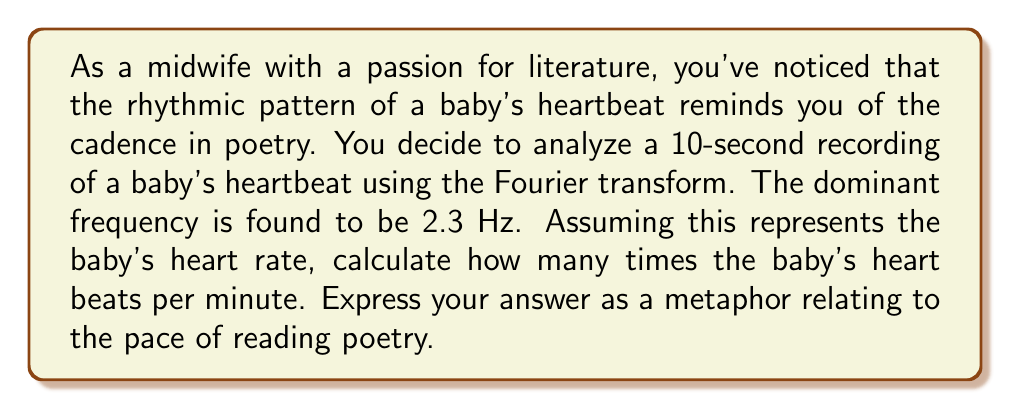Provide a solution to this math problem. To solve this problem, we need to follow these steps:

1. Understand the given information:
   - The dominant frequency from the Fourier transform is 2.3 Hz
   - Hz means cycles per second

2. Convert the frequency to beats per minute:
   $$\text{Beats per minute} = \text{Frequency (Hz)} \times 60 \text{ seconds/minute}$$
   $$\text{Beats per minute} = 2.3 \text{ Hz} \times 60 \text{ seconds/minute}$$
   $$\text{Beats per minute} = 138 \text{ beats/minute}$$

3. Relate this to poetry:
   In poetry, a common meter is iambic pentameter, which has 10 syllables per line. If we consider each heartbeat as a syllable, we can express the heart rate in terms of lines of iambic pentameter per minute:

   $$\text{Lines per minute} = \frac{138 \text{ beats/minute}}{10 \text{ syllables/line}} = 13.8 \text{ lines/minute}$$

4. Create a poetic metaphor:
   We can say the baby's heart beats at the pace of reading about 14 lines of iambic pentameter per minute, which is close to the rate of reading a sonnet (14 lines) in one minute.
Answer: The baby's heart beats at the pace of a sonnet's verse, with each minute's passage marking the completion of approximately 14 lines of iambic pentameter. 